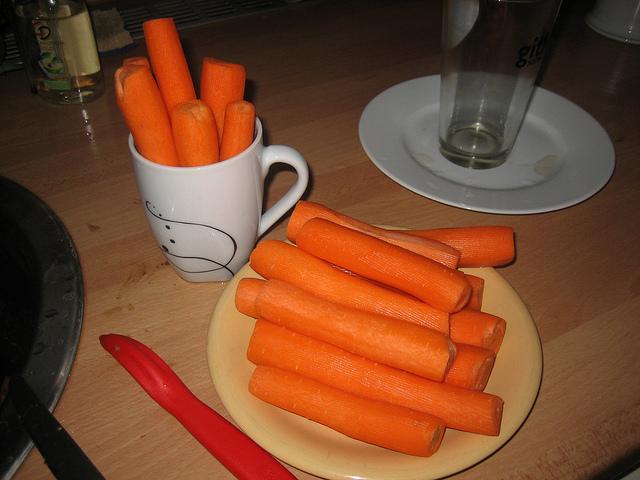How many carrots are there?
Write a very short answer. 16. How full is the glass?
Write a very short answer. Empty. What are these vegetables called?
Be succinct. Carrots. Is this a complete meal?
Concise answer only. No. 